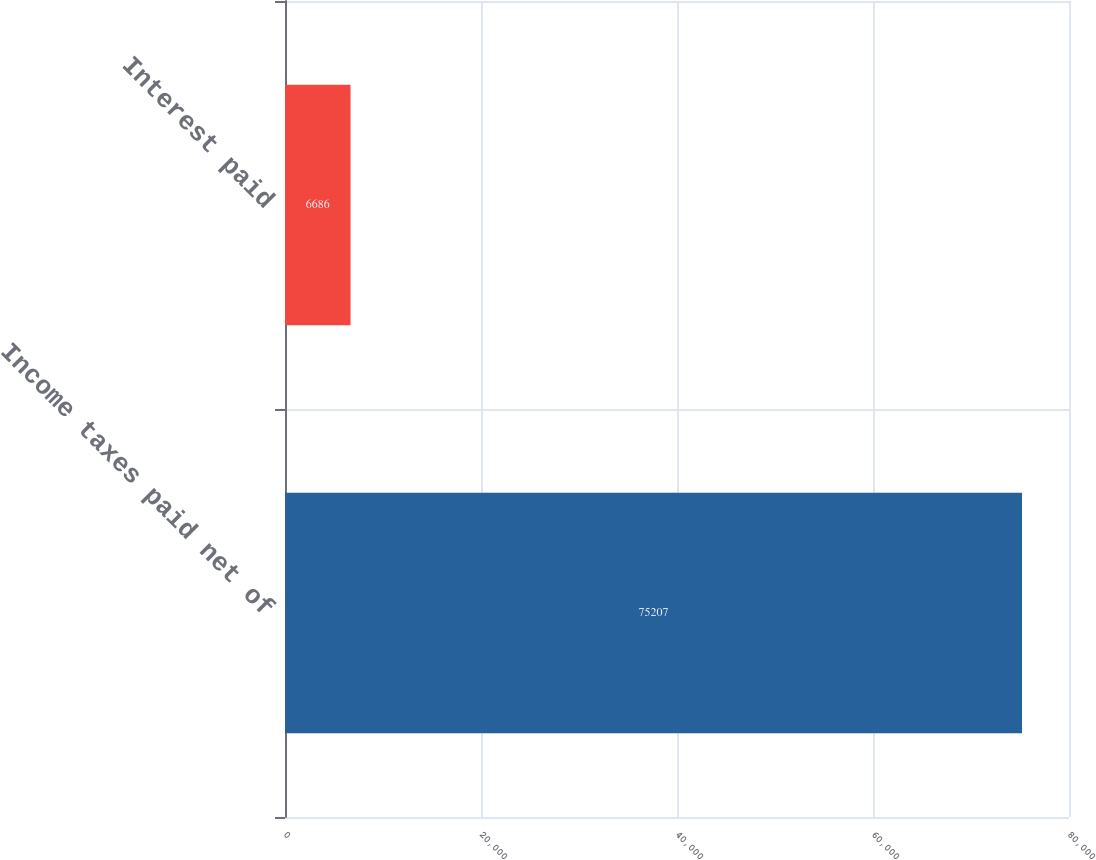Convert chart to OTSL. <chart><loc_0><loc_0><loc_500><loc_500><bar_chart><fcel>Income taxes paid net of<fcel>Interest paid<nl><fcel>75207<fcel>6686<nl></chart> 